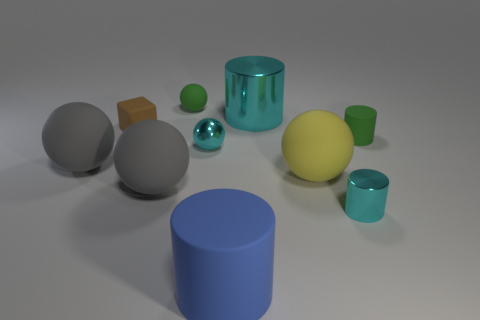Subtract all green cylinders. How many cylinders are left? 3 Subtract all small green cylinders. How many cylinders are left? 3 Subtract 0 yellow cubes. How many objects are left? 10 Subtract all cylinders. How many objects are left? 6 Subtract 1 cylinders. How many cylinders are left? 3 Subtract all purple cylinders. Subtract all red spheres. How many cylinders are left? 4 Subtract all cyan blocks. How many yellow spheres are left? 1 Subtract all large spheres. Subtract all cyan metal objects. How many objects are left? 4 Add 3 big matte cylinders. How many big matte cylinders are left? 4 Add 2 cylinders. How many cylinders exist? 6 